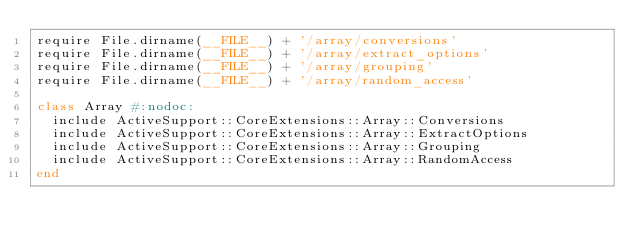Convert code to text. <code><loc_0><loc_0><loc_500><loc_500><_Ruby_>require File.dirname(__FILE__) + '/array/conversions'
require File.dirname(__FILE__) + '/array/extract_options'
require File.dirname(__FILE__) + '/array/grouping'
require File.dirname(__FILE__) + '/array/random_access'

class Array #:nodoc:
  include ActiveSupport::CoreExtensions::Array::Conversions
  include ActiveSupport::CoreExtensions::Array::ExtractOptions
  include ActiveSupport::CoreExtensions::Array::Grouping
  include ActiveSupport::CoreExtensions::Array::RandomAccess
end
</code> 